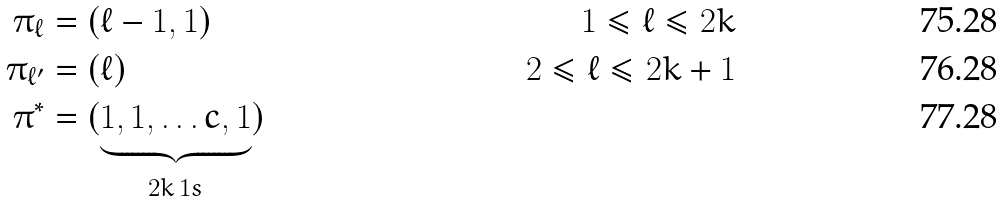<formula> <loc_0><loc_0><loc_500><loc_500>\pi _ { \ell } & = ( \ell - 1 , 1 ) & 1 \leq \ell \leq 2 k \\ \pi _ { \ell ^ { \prime } } & = ( \ell ) & 2 \leq \ell \leq 2 k + 1 \\ \pi ^ { * } & = ( \underbrace { 1 , 1 , \dots c , 1 } _ { 2 k \, 1 s } )</formula> 